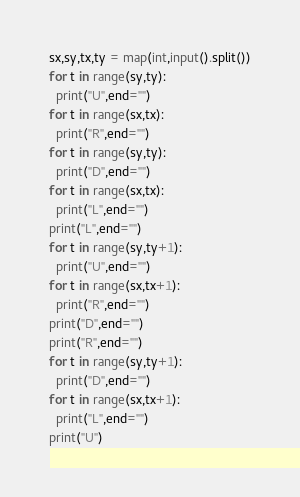<code> <loc_0><loc_0><loc_500><loc_500><_Python_>sx,sy,tx,ty = map(int,input().split())
for t in range(sy,ty):
  print("U",end="")
for t in range(sx,tx):
  print("R",end="")
for t in range(sy,ty):
  print("D",end="")
for t in range(sx,tx):
  print("L",end="")
print("L",end="")
for t in range(sy,ty+1):
  print("U",end="")
for t in range(sx,tx+1):
  print("R",end="")
print("D",end="")
print("R",end="")
for t in range(sy,ty+1):
  print("D",end="")
for t in range(sx,tx+1):
  print("L",end="")
print("U")</code> 